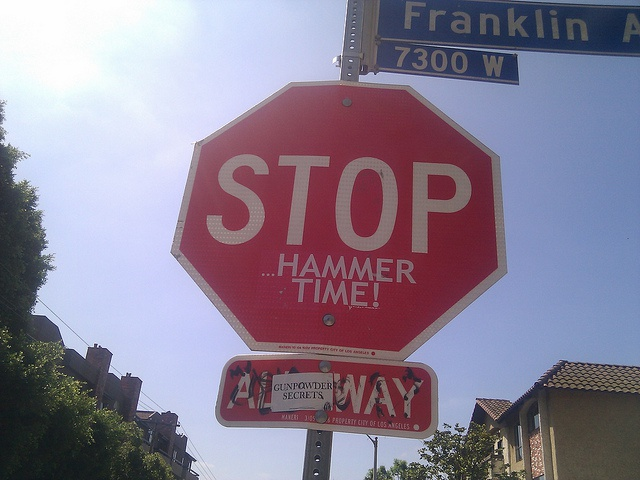Describe the objects in this image and their specific colors. I can see a stop sign in white, brown, and gray tones in this image. 